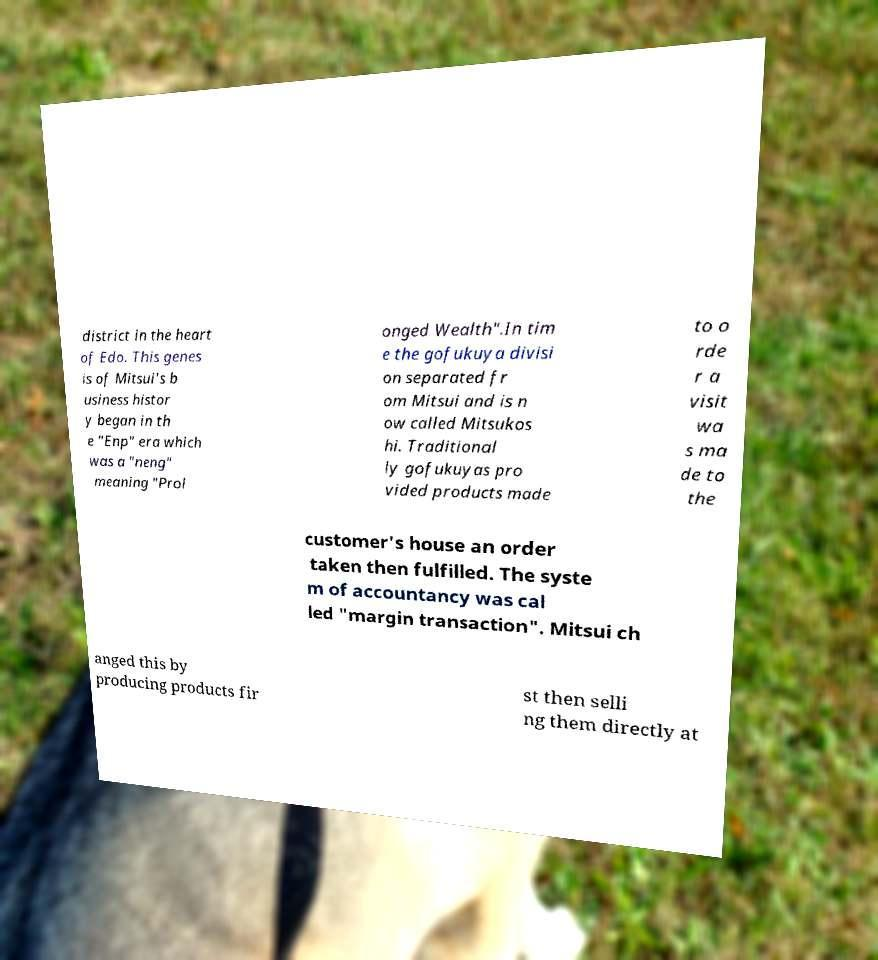Could you assist in decoding the text presented in this image and type it out clearly? district in the heart of Edo. This genes is of Mitsui's b usiness histor y began in th e "Enp" era which was a "neng" meaning "Prol onged Wealth".In tim e the gofukuya divisi on separated fr om Mitsui and is n ow called Mitsukos hi. Traditional ly gofukuyas pro vided products made to o rde r a visit wa s ma de to the customer's house an order taken then fulfilled. The syste m of accountancy was cal led "margin transaction". Mitsui ch anged this by producing products fir st then selli ng them directly at 